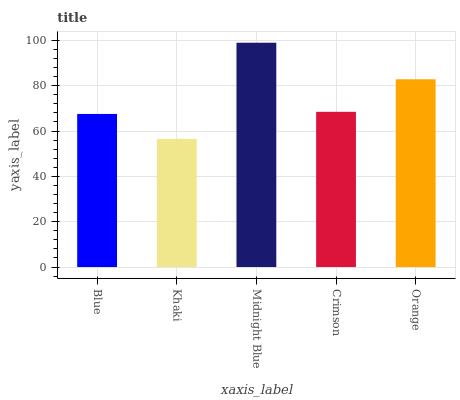Is Khaki the minimum?
Answer yes or no. Yes. Is Midnight Blue the maximum?
Answer yes or no. Yes. Is Midnight Blue the minimum?
Answer yes or no. No. Is Khaki the maximum?
Answer yes or no. No. Is Midnight Blue greater than Khaki?
Answer yes or no. Yes. Is Khaki less than Midnight Blue?
Answer yes or no. Yes. Is Khaki greater than Midnight Blue?
Answer yes or no. No. Is Midnight Blue less than Khaki?
Answer yes or no. No. Is Crimson the high median?
Answer yes or no. Yes. Is Crimson the low median?
Answer yes or no. Yes. Is Blue the high median?
Answer yes or no. No. Is Orange the low median?
Answer yes or no. No. 